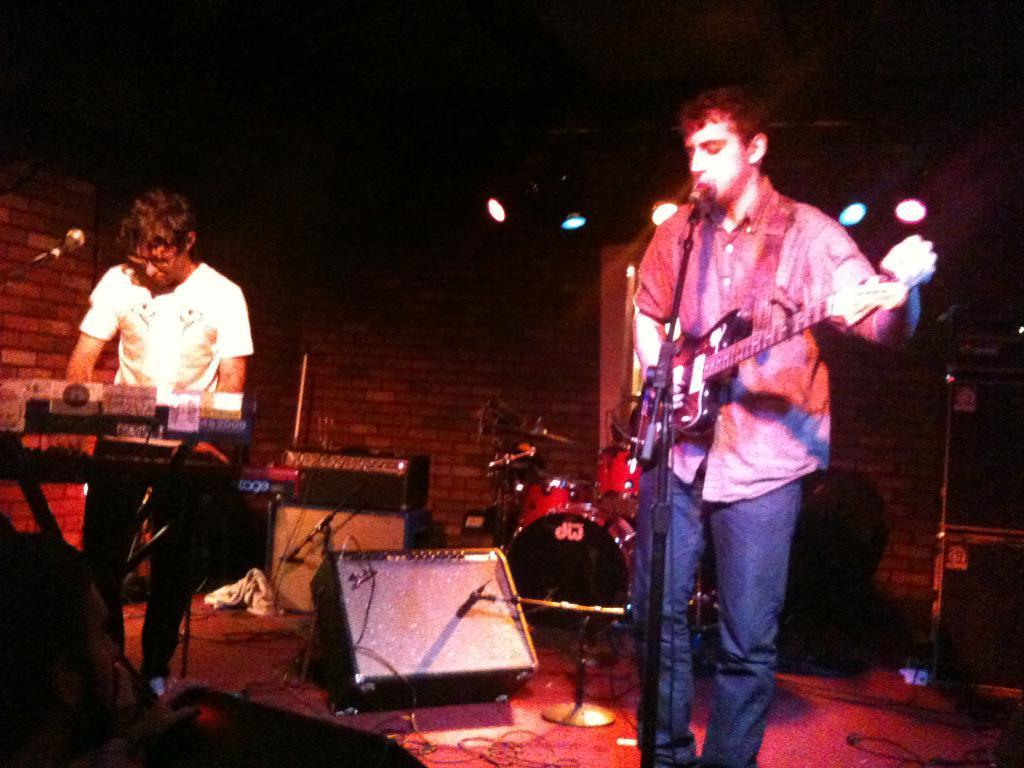How would you summarize this image in a sentence or two? In this picture there is a man who is wearing a white shirt. There is a mic. There is another man who is playing a guitar and is also singing. At the background there is a light. There is a brick wall at the background. There are some musical instruments at the background. 